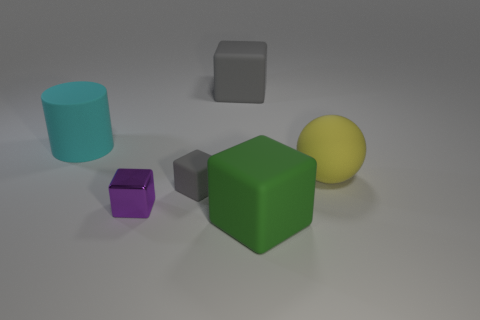Subtract all red blocks. Subtract all brown cylinders. How many blocks are left? 4 Add 2 gray metallic objects. How many objects exist? 8 Subtract all blocks. How many objects are left? 2 Add 5 large yellow balls. How many large yellow balls are left? 6 Add 1 tiny red rubber things. How many tiny red rubber things exist? 1 Subtract 0 brown cylinders. How many objects are left? 6 Subtract all big gray cubes. Subtract all matte cylinders. How many objects are left? 4 